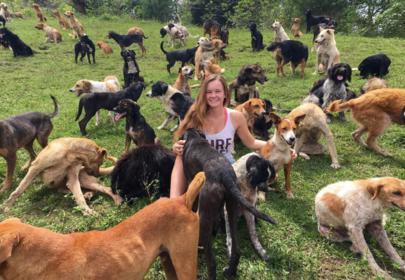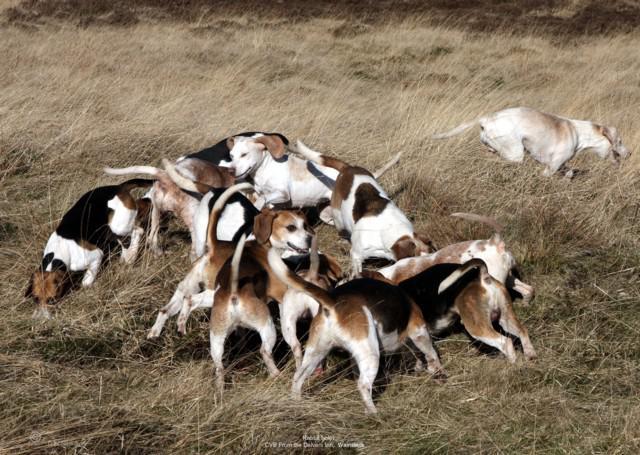The first image is the image on the left, the second image is the image on the right. For the images displayed, is the sentence "At least one human face is visible." factually correct? Answer yes or no. Yes. The first image is the image on the left, the second image is the image on the right. Analyze the images presented: Is the assertion "Left image includes a person with a group of dogs." valid? Answer yes or no. Yes. 